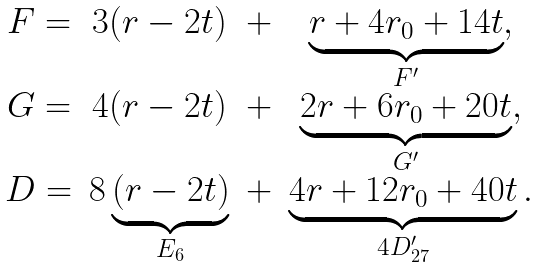<formula> <loc_0><loc_0><loc_500><loc_500>\begin{matrix} F = & 3 ( r - 2 t ) & + & \underbrace { r + 4 r _ { 0 } + 1 4 t } _ { F ^ { \prime } } , \\ G = & 4 ( r - 2 t ) & + & \underbrace { 2 r + 6 r _ { 0 } + 2 0 t } _ { G ^ { \prime } } , \\ D = & 8 \underbrace { ( r - 2 t ) } _ { E _ { 6 } } & + & \underbrace { 4 r + 1 2 r _ { 0 } + 4 0 t } _ { 4 D ^ { \prime } _ { 2 7 } } . \end{matrix}</formula> 